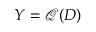<formula> <loc_0><loc_0><loc_500><loc_500>Y = \mathcal { Q } ( D )</formula> 